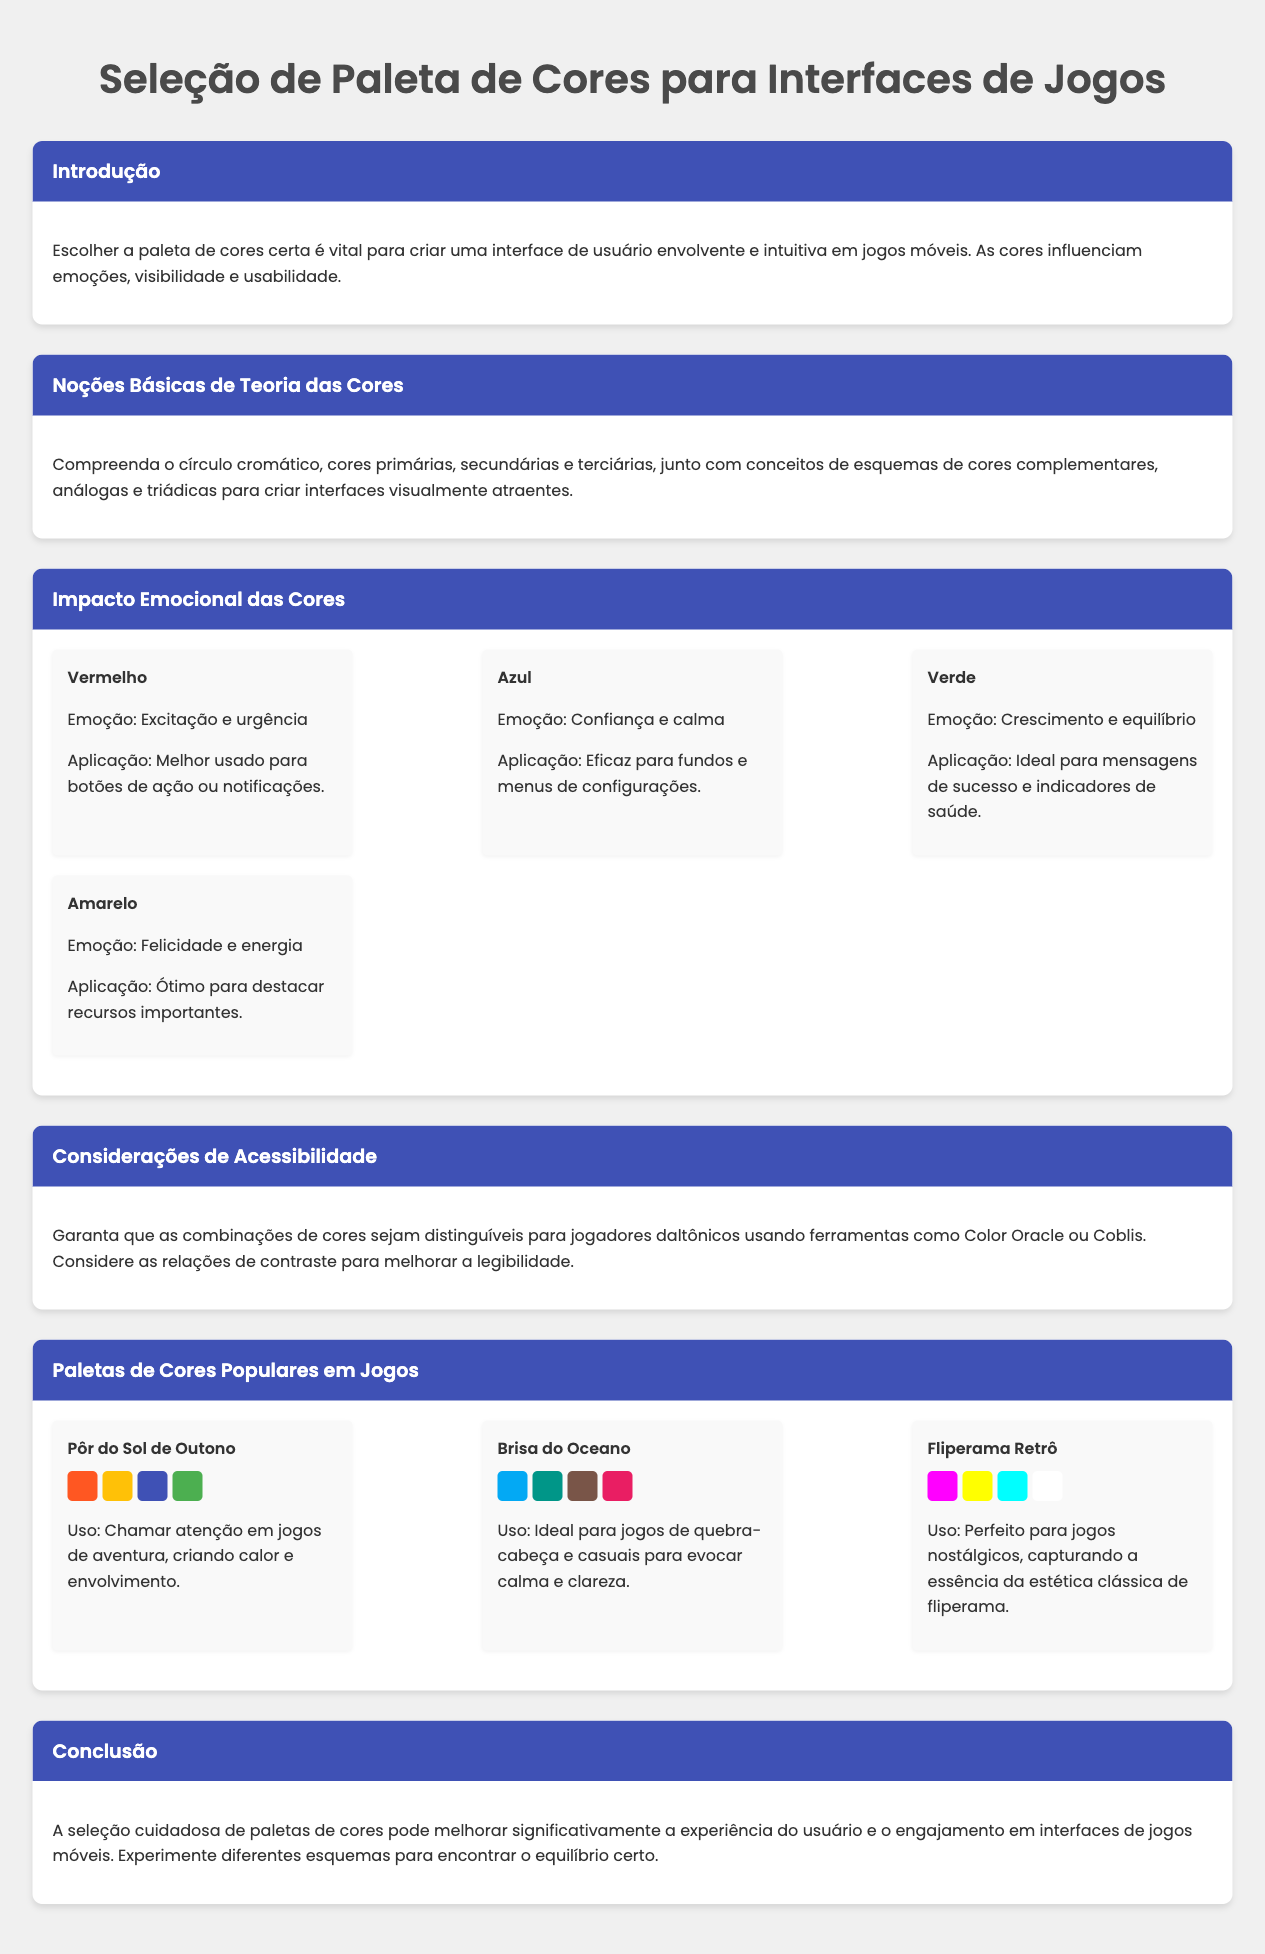qual é o título do documento? O título é indicado no elemento <title> do código HTML.
Answer: Seleção de Paleta de Cores para Interfaces de Jogos o que a seção "Impacto Emocional das Cores" menciona sobre a cor azul? A seção detalha a emoção associada à cor azul e sua aplicação.
Answer: Confiança e calma quais são as cores mencionadas na paleta "Pôr do Sol de Outono"? A paleta inclui quatro cores, que são listadas no conteúdo da seção.
Answer: Laranja, Amarelo, Azul, Verde quantas paletas de cores populares são apresentadas no documento? O número de paletas pode ser contado através das seções individuais.
Answer: Três o que se deve considerar para acessibilidade ao escolher cores? A seção aborda a importância de algumas ferramentas para garantir acessibilidade.
Answer: Combinações de cores distinguíveis qual emoção é associada à cor verde? A emoção associada pode ser encontrada na descrição da cor verde.
Answer: Crescimento e equilíbrio qual é a cor relacionada à felicidade na seção de cores emocionais? A descrição da cor amarela fornece essa informação.
Answer: Amarelo qual é a cor do texto utilizado no cabeçalho das seções? O estilo CSS descreve a cor utilizada para o texto nos cabeçalhos.
Answer: Branco 